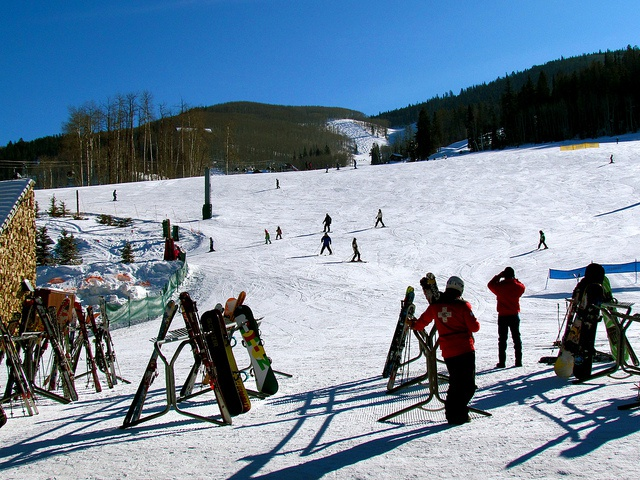Describe the objects in this image and their specific colors. I can see people in blue, black, maroon, and gray tones, snowboard in blue, black, white, and teal tones, snowboard in blue, black, darkgreen, maroon, and gray tones, people in blue, black, maroon, lightgray, and darkgray tones, and snowboard in blue, black, gray, olive, and lightgray tones in this image. 